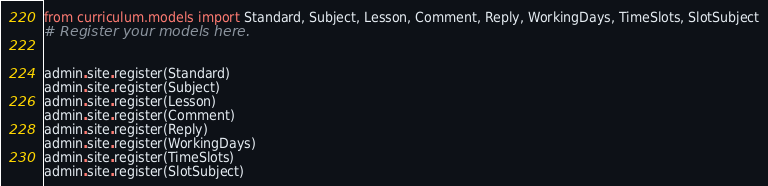<code> <loc_0><loc_0><loc_500><loc_500><_Python_>from curriculum.models import Standard, Subject, Lesson, Comment, Reply, WorkingDays, TimeSlots, SlotSubject
# Register your models here.


admin.site.register(Standard)
admin.site.register(Subject)
admin.site.register(Lesson)
admin.site.register(Comment)
admin.site.register(Reply)
admin.site.register(WorkingDays)
admin.site.register(TimeSlots)
admin.site.register(SlotSubject)
</code> 